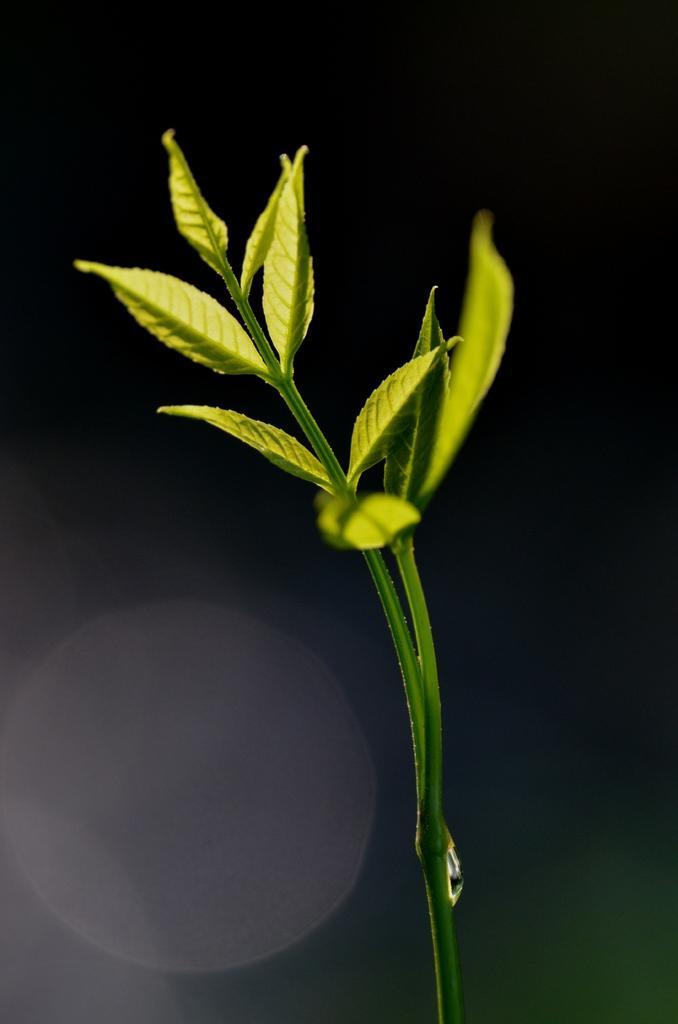Could you give a brief overview of what you see in this image? In the image we can see a stem and leaves, there is a water droplet on the steam. 